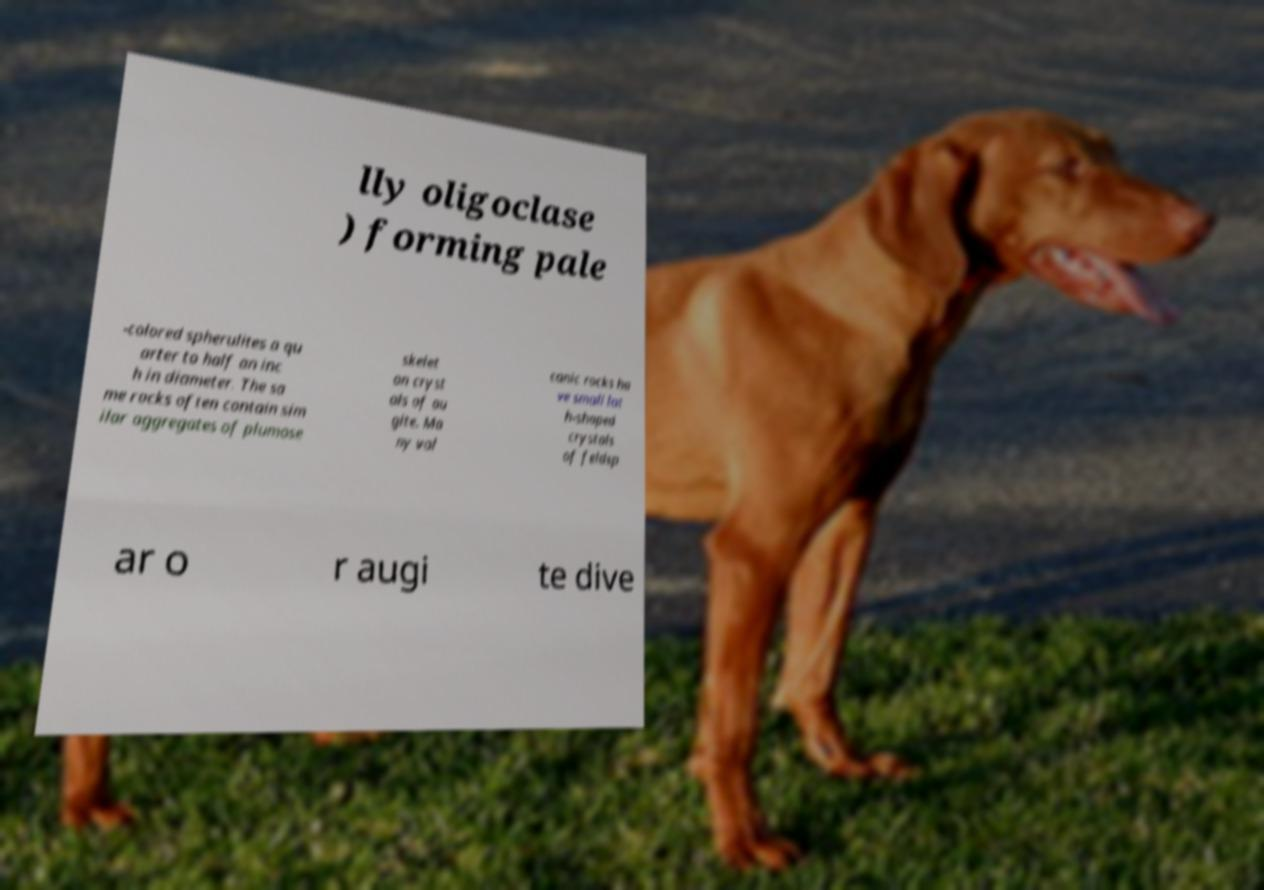What messages or text are displayed in this image? I need them in a readable, typed format. lly oligoclase ) forming pale -colored spherulites a qu arter to half an inc h in diameter. The sa me rocks often contain sim ilar aggregates of plumose skelet on cryst als of au gite. Ma ny vol canic rocks ha ve small lat h-shaped crystals of feldsp ar o r augi te dive 